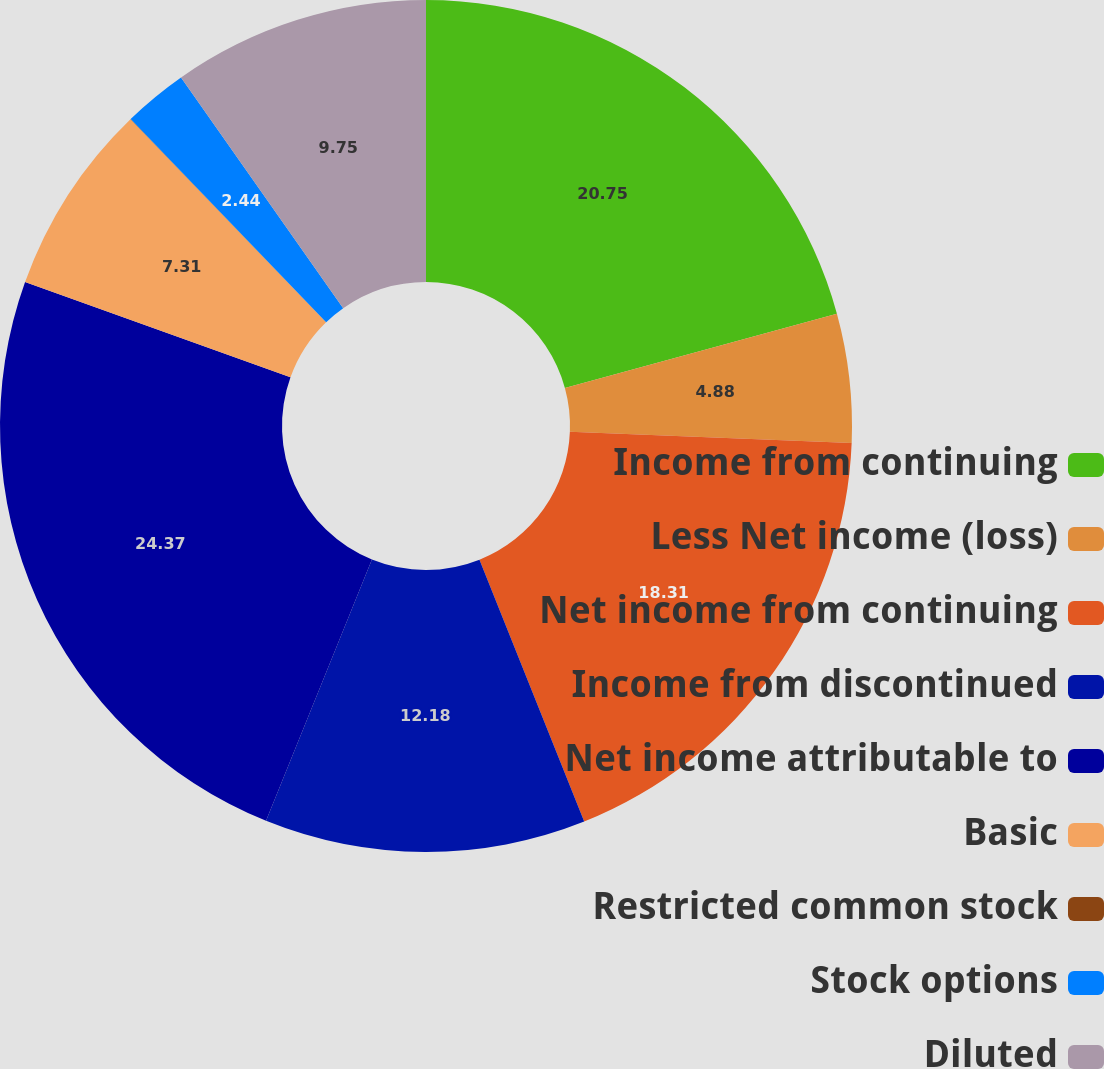<chart> <loc_0><loc_0><loc_500><loc_500><pie_chart><fcel>Income from continuing<fcel>Less Net income (loss)<fcel>Net income from continuing<fcel>Income from discontinued<fcel>Net income attributable to<fcel>Basic<fcel>Restricted common stock<fcel>Stock options<fcel>Diluted<nl><fcel>20.75%<fcel>4.88%<fcel>18.31%<fcel>12.18%<fcel>24.36%<fcel>7.31%<fcel>0.01%<fcel>2.44%<fcel>9.75%<nl></chart> 